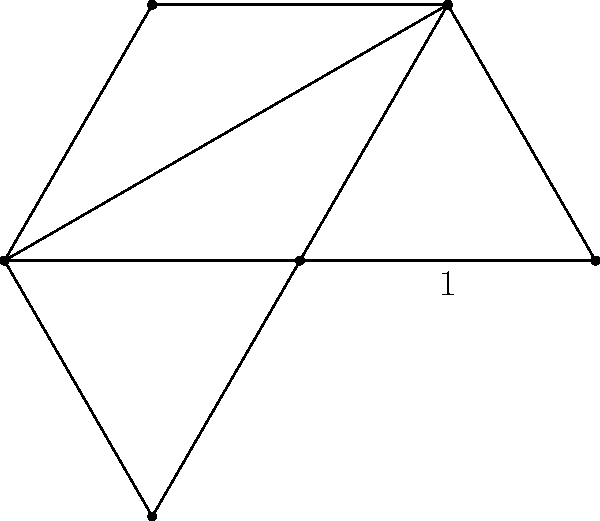As part of your migraine awareness campaign, you're designing a hexagonal logo to represent the six main triggers of migraines. If each side of the hexagon represents one trigger and has a length of 1 unit, what is the perimeter of the entire logo? Let's approach this step-by-step:

1) First, recall that a regular hexagon has 6 equal sides.

2) We're given that each side has a length of 1 unit.

3) To find the perimeter, we need to add up the lengths of all sides.

4) Since there are 6 sides, and each side is 1 unit long, we can express this mathematically as:

   $$\text{Perimeter} = 6 \times 1$$

5) Simplifying:

   $$\text{Perimeter} = 6\text{ units}$$

This result means that the total distance around the hexagonal logo, representing the six main migraine triggers, is 6 units.
Answer: $6\text{ units}$ 